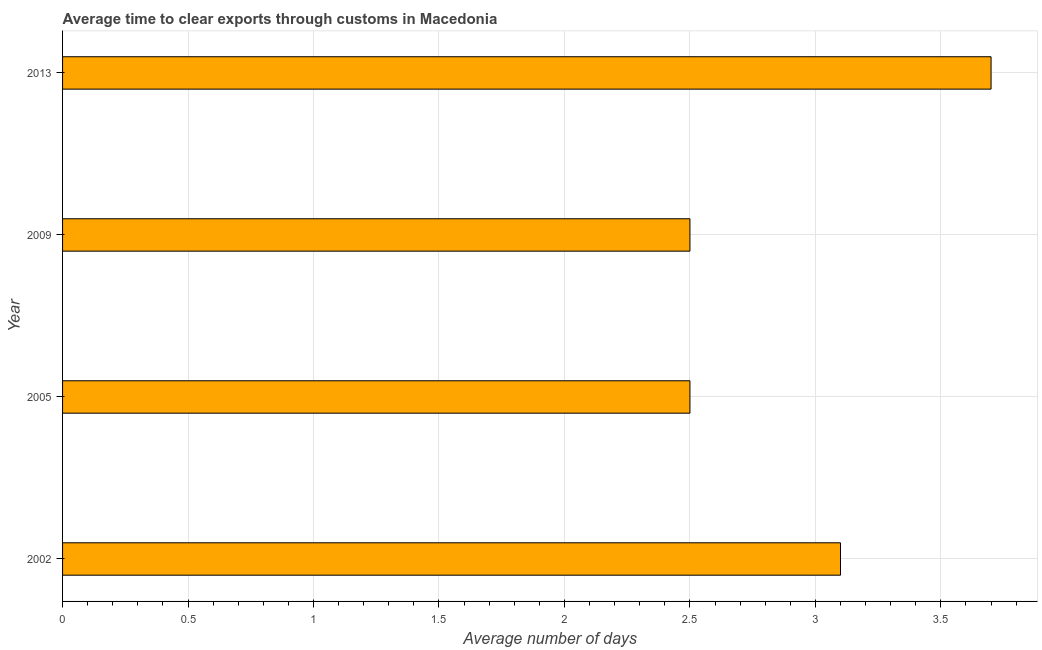Does the graph contain grids?
Your answer should be compact. Yes. What is the title of the graph?
Ensure brevity in your answer.  Average time to clear exports through customs in Macedonia. What is the label or title of the X-axis?
Provide a succinct answer. Average number of days. What is the time to clear exports through customs in 2002?
Your response must be concise. 3.1. In which year was the time to clear exports through customs maximum?
Offer a terse response. 2013. What is the average time to clear exports through customs per year?
Provide a short and direct response. 2.95. What is the median time to clear exports through customs?
Your answer should be compact. 2.8. In how many years, is the time to clear exports through customs greater than 0.6 days?
Provide a short and direct response. 4. What is the ratio of the time to clear exports through customs in 2002 to that in 2013?
Keep it short and to the point. 0.84. Is the sum of the time to clear exports through customs in 2005 and 2013 greater than the maximum time to clear exports through customs across all years?
Offer a very short reply. Yes. Are the values on the major ticks of X-axis written in scientific E-notation?
Your answer should be very brief. No. What is the Average number of days of 2005?
Your response must be concise. 2.5. What is the Average number of days of 2013?
Provide a short and direct response. 3.7. What is the difference between the Average number of days in 2002 and 2013?
Provide a short and direct response. -0.6. What is the difference between the Average number of days in 2009 and 2013?
Your answer should be very brief. -1.2. What is the ratio of the Average number of days in 2002 to that in 2005?
Ensure brevity in your answer.  1.24. What is the ratio of the Average number of days in 2002 to that in 2009?
Provide a short and direct response. 1.24. What is the ratio of the Average number of days in 2002 to that in 2013?
Provide a succinct answer. 0.84. What is the ratio of the Average number of days in 2005 to that in 2009?
Ensure brevity in your answer.  1. What is the ratio of the Average number of days in 2005 to that in 2013?
Your answer should be compact. 0.68. What is the ratio of the Average number of days in 2009 to that in 2013?
Make the answer very short. 0.68. 